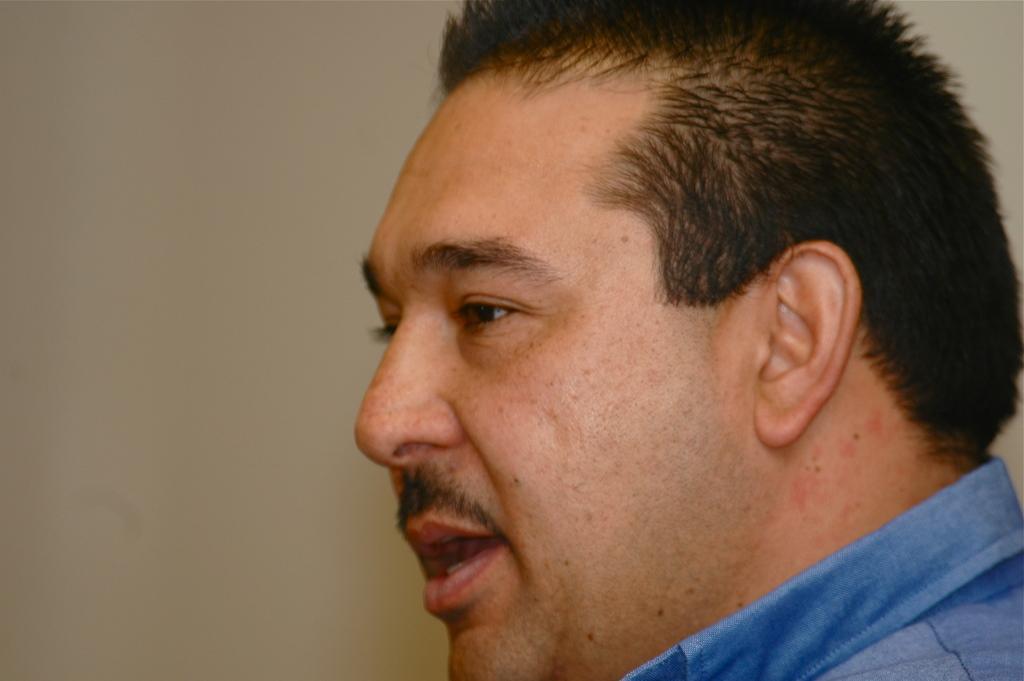In one or two sentences, can you explain what this image depicts? In this picture, there is a man facing towards the left. He is wearing blue shirt. 